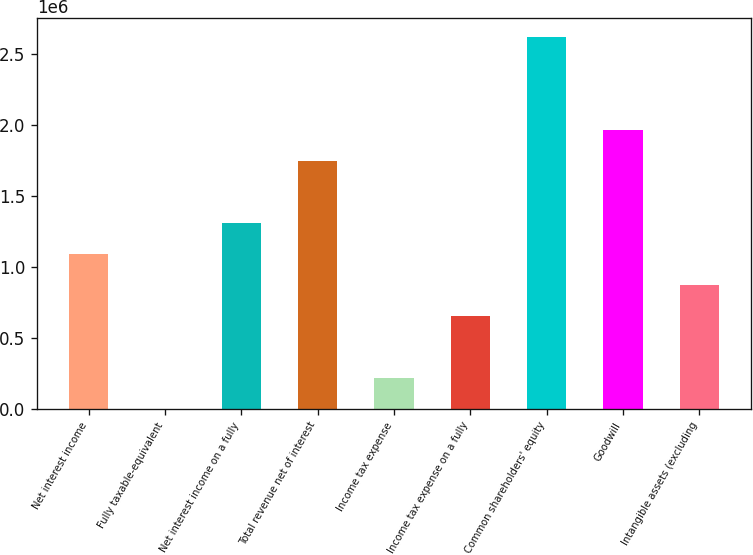<chart> <loc_0><loc_0><loc_500><loc_500><bar_chart><fcel>Net interest income<fcel>Fully taxable-equivalent<fcel>Net interest income on a fully<fcel>Total revenue net of interest<fcel>Income tax expense<fcel>Income tax expense on a fully<fcel>Common shareholders' equity<fcel>Goodwill<fcel>Intangible assets (excluding<nl><fcel>1.09297e+06<fcel>215<fcel>1.31152e+06<fcel>1.74862e+06<fcel>218766<fcel>655868<fcel>2.62283e+06<fcel>1.96717e+06<fcel>874419<nl></chart> 